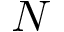<formula> <loc_0><loc_0><loc_500><loc_500>N</formula> 